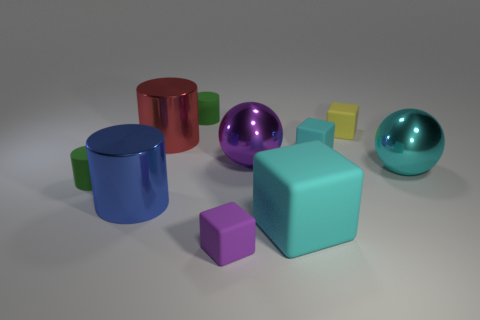Subtract all blue cylinders. How many cylinders are left? 3 Subtract all red balls. How many cyan blocks are left? 2 Subtract all yellow cubes. How many cubes are left? 3 Subtract all red cylinders. Subtract all red spheres. How many cylinders are left? 3 Subtract all spheres. How many objects are left? 8 Add 7 matte cylinders. How many matte cylinders are left? 9 Add 2 large cyan matte blocks. How many large cyan matte blocks exist? 3 Subtract 1 cyan balls. How many objects are left? 9 Subtract all small cylinders. Subtract all big red metal objects. How many objects are left? 7 